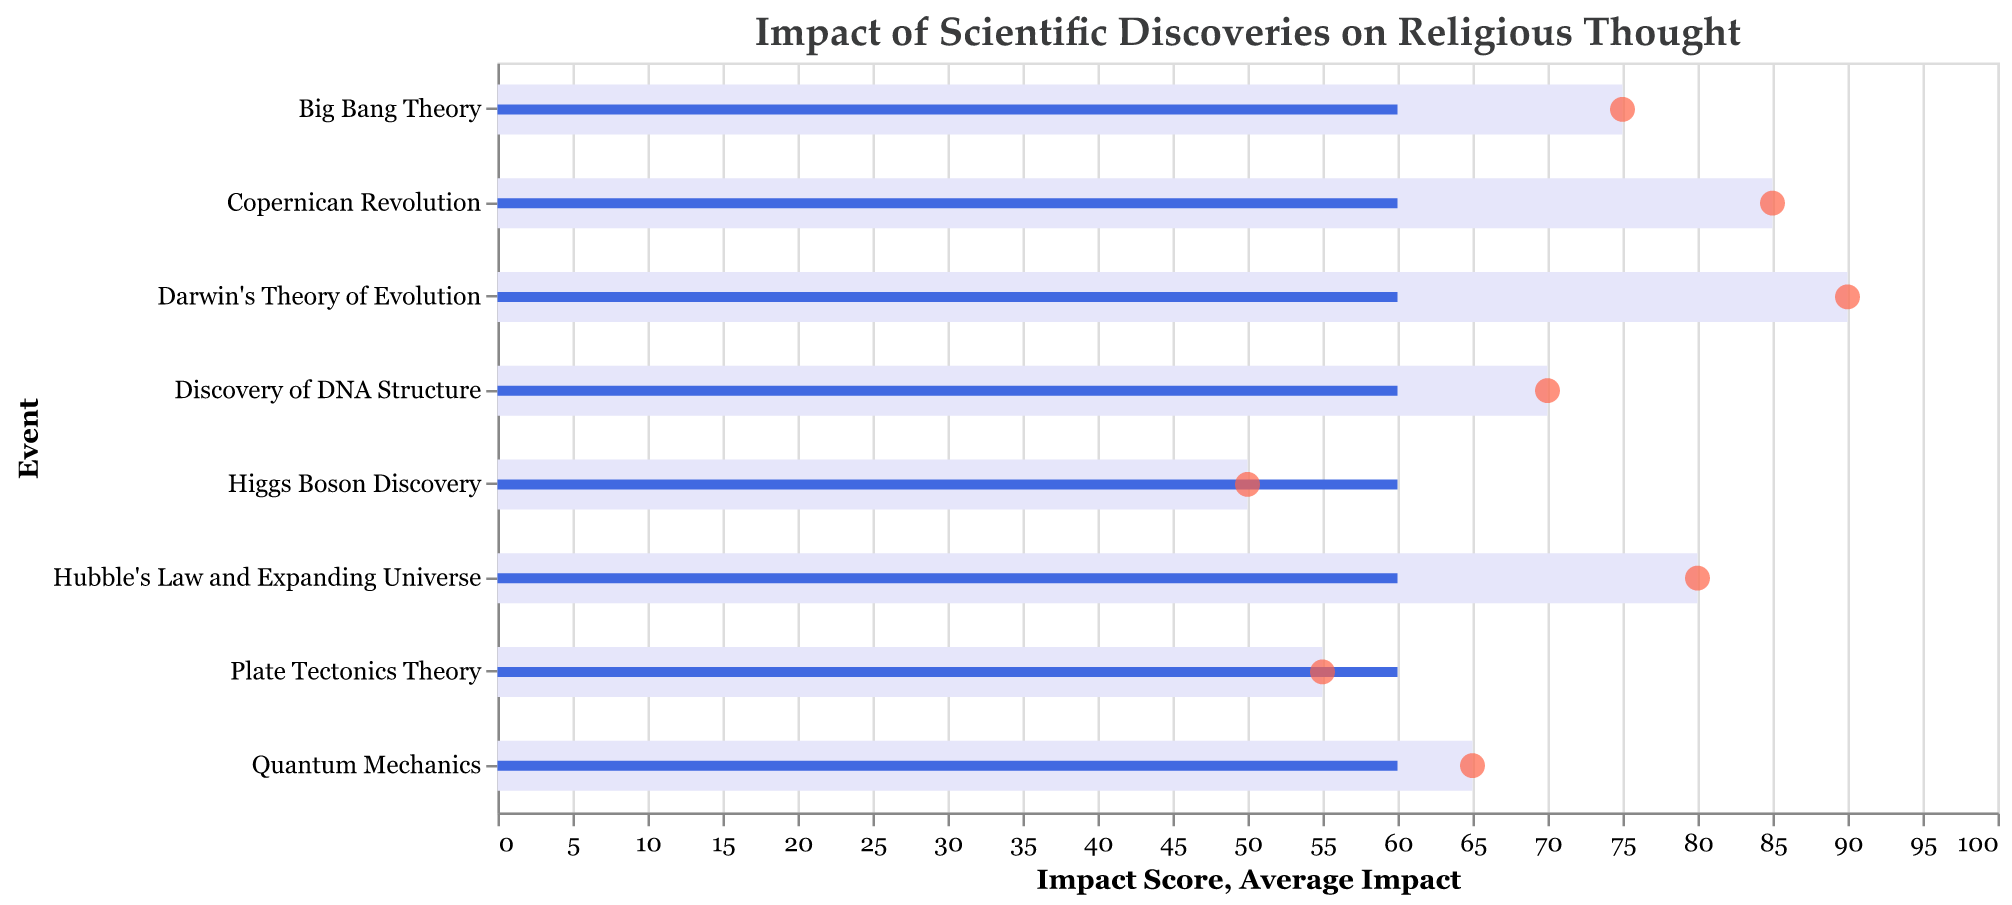What is the title of the chart? The title of the chart is displayed at the top and it reads "Impact of Scientific Discoveries on Religious Thought".
Answer: Impact of Scientific Discoveries on Religious Thought How many scientific discoveries are shown in the chart? By counting the bars in the chart, we can see the number of scientific discoveries illustrated. There are 8 bars.
Answer: 8 Which scientific discovery has the highest impact score on religious thought? Look for the bar that extends the farthest to the right since it represents the highest impact score. "Darwin's Theory of Evolution" has the highest impact score at 90.
Answer: Darwin's Theory of Evolution Which event had the least impact on religious thought according to the chart? Identify the event with the shortest bar, which represents the lowest impact score. The "Higgs Boson Discovery" has the lowest impact score at 50.
Answer: Higgs Boson Discovery What is the impact score for the Copernican Revolution? Locate the bar labeled "Copernican Revolution" and check the x-axis value where the bar ends. The impact score is 85.
Answer: 85 Which discovery occurred in the most recent year? Look at the temporal data associated with each event and find the most recent year. The "Higgs Boson Discovery" occurred in 2012.
Answer: Higgs Boson Discovery Compare the impact scores of the Big Bang Theory and Quantum Mechanics. Which is higher and by how much? Identify the impact scores for both events from their respective bars. The Big Bang Theory has an impact score of 75, while Quantum Mechanics has a score of 65. The difference is 75 - 65 = 10.
Answer: Big Bang Theory by 10 What is the average impact score for all the scientific discoveries combined? According to the data, the average impact score is given as 60, shown by the blue bars as a reference line.
Answer: 60 How does the impact of the Plate Tectonics Theory compare to the average impact score? Locate the Plate Tectonics Theory bar and its value (55), then compare it to the Average Impact Score line (60). 55 is 5 points lower than 60.
Answer: 5 points lower Which discoveries impact score is closest to the average impact score? Check which bar has an impact score that is closest to 60. The "Quantum Mechanics" discovery has a score of 65, which is the closest to 60 among the given discoveries.
Answer: Quantum Mechanics 